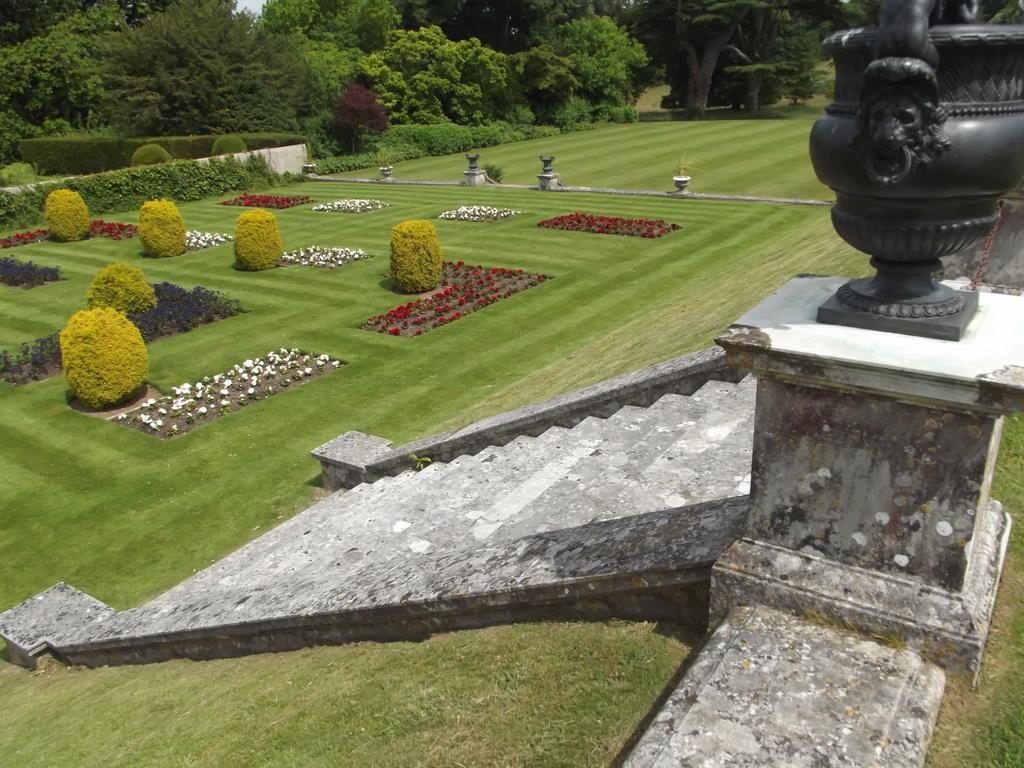Please provide a concise description of this image. There are trees in the back side of an image and in the middle it is a staircase. Right side it is a statue. 